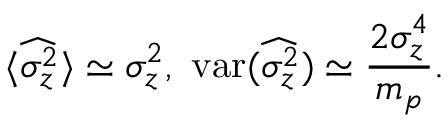<formula> <loc_0><loc_0><loc_500><loc_500>\langle \widehat { \sigma _ { z } ^ { 2 } } \rangle \simeq \sigma _ { z } ^ { 2 } , v a r ( \widehat { \sigma _ { z } ^ { 2 } } ) \simeq \frac { 2 \sigma _ { z } ^ { 4 } } { m _ { p } } .</formula> 